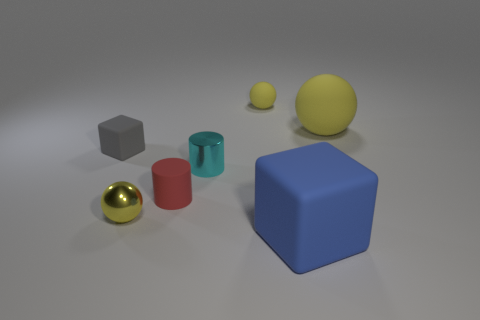What number of small cyan cylinders are left of the small gray block?
Your answer should be very brief. 0. Is there a small red cube made of the same material as the cyan cylinder?
Ensure brevity in your answer.  No. The big matte thing that is the same color as the tiny metal sphere is what shape?
Offer a very short reply. Sphere. There is a matte cylinder that is right of the small yellow metallic sphere; what color is it?
Offer a terse response. Red. Are there the same number of small cyan metallic cylinders in front of the blue object and yellow matte spheres that are on the left side of the tiny yellow metallic object?
Offer a terse response. Yes. There is a ball to the right of the yellow thing that is behind the big yellow matte object; what is its material?
Keep it short and to the point. Rubber. How many things are matte cylinders or yellow spheres on the right side of the tiny matte cylinder?
Give a very brief answer. 3. There is a gray block that is made of the same material as the small red object; what is its size?
Ensure brevity in your answer.  Small. Are there more blue things that are in front of the blue matte object than large gray rubber cylinders?
Give a very brief answer. No. There is a object that is left of the rubber cylinder and right of the small gray rubber cube; what is its size?
Ensure brevity in your answer.  Small. 